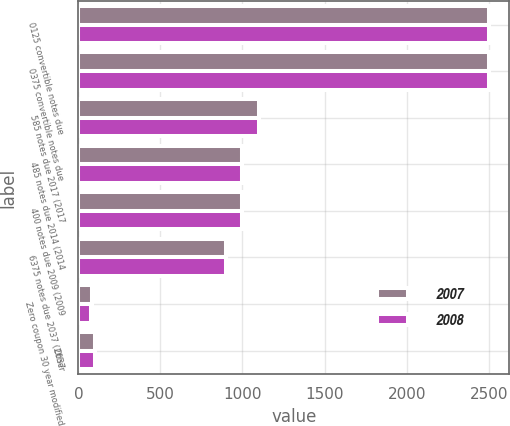Convert chart to OTSL. <chart><loc_0><loc_0><loc_500><loc_500><stacked_bar_chart><ecel><fcel>0125 convertible notes due<fcel>0375 convertible notes due<fcel>585 notes due 2017 (2017<fcel>485 notes due 2014 (2014<fcel>400 notes due 2009 (2009<fcel>6375 notes due 2037 (2037<fcel>Zero coupon 30 year modified<fcel>Other<nl><fcel>2007<fcel>2500<fcel>2500<fcel>1099<fcel>1000<fcel>1000<fcel>899<fcel>81<fcel>100<nl><fcel>2008<fcel>2500<fcel>2500<fcel>1099<fcel>1000<fcel>999<fcel>899<fcel>80<fcel>100<nl></chart> 